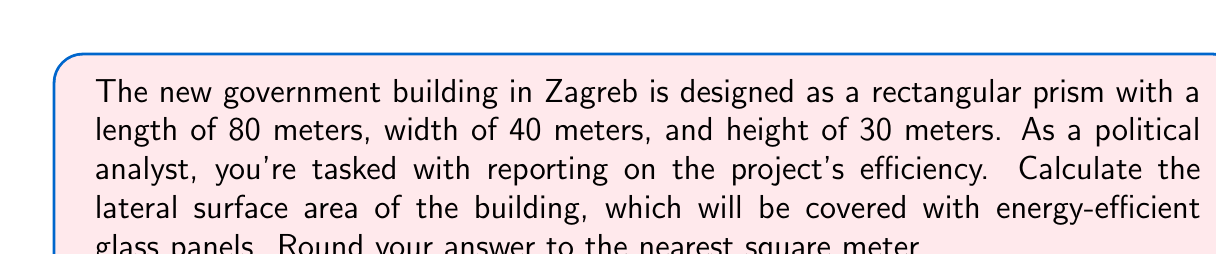What is the answer to this math problem? To calculate the lateral surface area of a rectangular prism, we need to follow these steps:

1. Recall the formula for lateral surface area of a rectangular prism:
   $$ \text{Lateral Surface Area} = 2h(l + w) $$
   where $h$ is height, $l$ is length, and $w$ is width.

2. Substitute the given dimensions:
   $h = 30$ m, $l = 80$ m, $w = 40$ m

3. Apply the formula:
   $$ \begin{align*}
   \text{Lateral Surface Area} &= 2 \cdot 30 \cdot (80 + 40) \\
   &= 60 \cdot 120 \\
   &= 7,200 \text{ m}^2
   \end{align*} $$

4. The result is already a whole number, so no rounding is necessary.

[asy]
import three;

size(200);
currentprojection=perspective(6,3,2);

draw(box((0,0,0),(80,40,30)));
label("80 m",(-5,20,0),W);
label("40 m",(80,45,0),N);
label("30 m",(80,0,-5),E);
[/asy]
Answer: 7,200 m² 